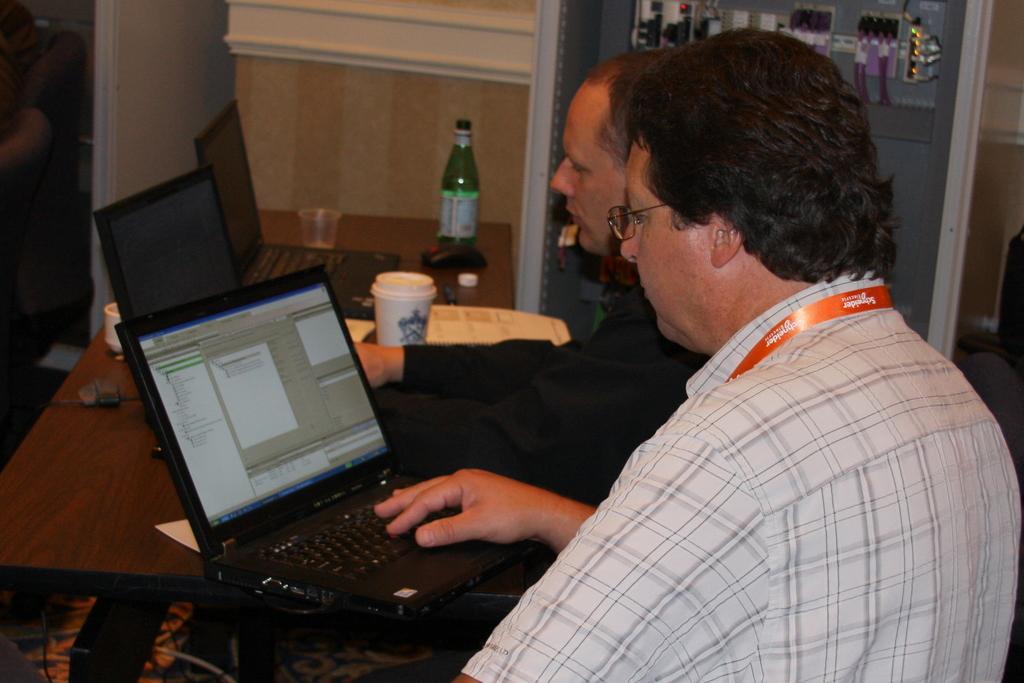Please provide a concise description of this image. In the image we can see there are people wearing clothes, this person is wearing identity card and spectacles. In front of them there are systems, this is a table, carpet, glass, mouse, bottle cap and bottle. This is a cable wire and other object. 